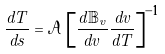<formula> <loc_0><loc_0><loc_500><loc_500>\frac { d T } { d s } = \mathcal { A } \left [ \frac { d \mathbb { B } _ { v } } { d v } \frac { d v } { d T } \right ] ^ { - 1 }</formula> 